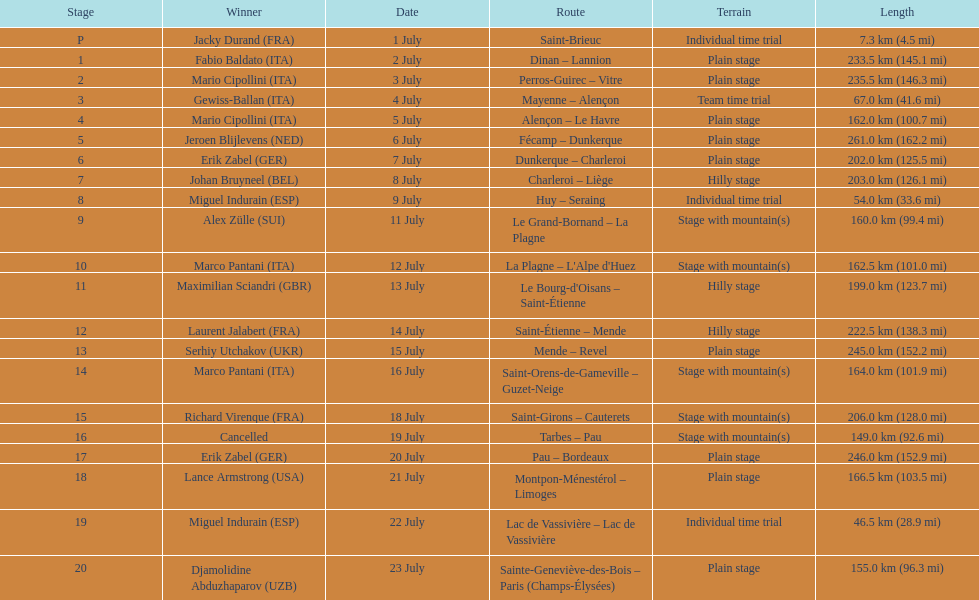How many routes have below 100 km total? 4. 